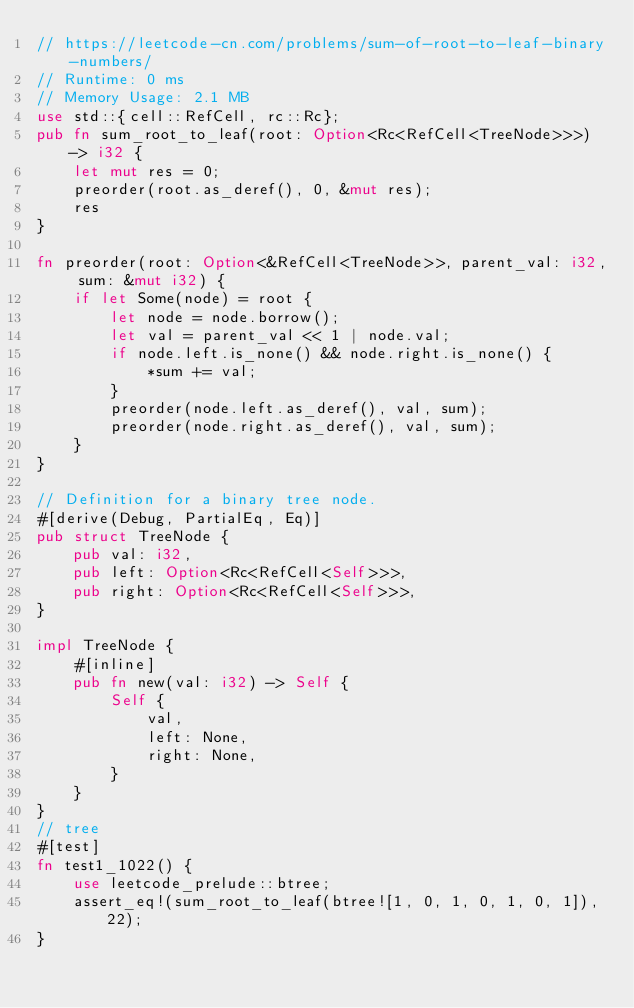<code> <loc_0><loc_0><loc_500><loc_500><_Rust_>// https://leetcode-cn.com/problems/sum-of-root-to-leaf-binary-numbers/
// Runtime: 0 ms
// Memory Usage: 2.1 MB
use std::{cell::RefCell, rc::Rc};
pub fn sum_root_to_leaf(root: Option<Rc<RefCell<TreeNode>>>) -> i32 {
    let mut res = 0;
    preorder(root.as_deref(), 0, &mut res);
    res
}

fn preorder(root: Option<&RefCell<TreeNode>>, parent_val: i32, sum: &mut i32) {
    if let Some(node) = root {
        let node = node.borrow();
        let val = parent_val << 1 | node.val;
        if node.left.is_none() && node.right.is_none() {
            *sum += val;
        }
        preorder(node.left.as_deref(), val, sum);
        preorder(node.right.as_deref(), val, sum);
    }
}

// Definition for a binary tree node.
#[derive(Debug, PartialEq, Eq)]
pub struct TreeNode {
    pub val: i32,
    pub left: Option<Rc<RefCell<Self>>>,
    pub right: Option<Rc<RefCell<Self>>>,
}

impl TreeNode {
    #[inline]
    pub fn new(val: i32) -> Self {
        Self {
            val,
            left: None,
            right: None,
        }
    }
}
// tree
#[test]
fn test1_1022() {
    use leetcode_prelude::btree;
    assert_eq!(sum_root_to_leaf(btree![1, 0, 1, 0, 1, 0, 1]), 22);
}
</code> 